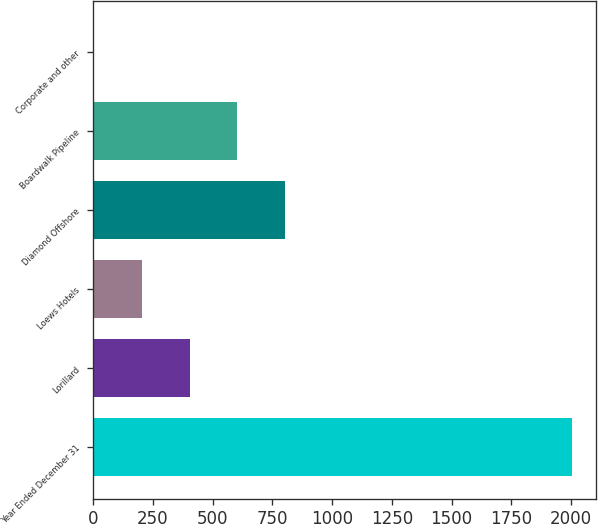<chart> <loc_0><loc_0><loc_500><loc_500><bar_chart><fcel>Year Ended December 31<fcel>Lorillard<fcel>Loews Hotels<fcel>Diamond Offshore<fcel>Boardwalk Pipeline<fcel>Corporate and other<nl><fcel>2005<fcel>403.48<fcel>203.29<fcel>803.86<fcel>603.67<fcel>3.1<nl></chart> 